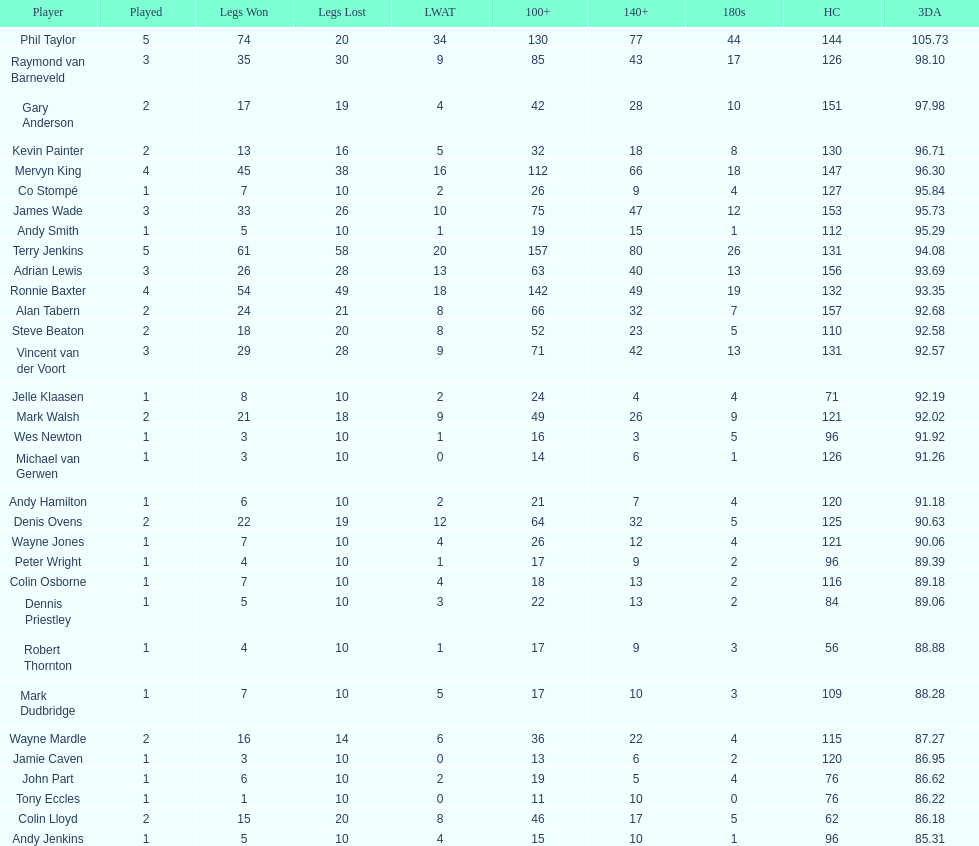How many players in the 2009 world matchplay won at least 30 legs? 6. 